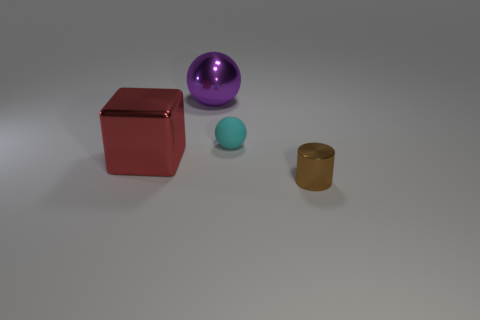Add 4 small brown cylinders. How many objects exist? 8 Subtract all cubes. How many objects are left? 3 Add 2 tiny balls. How many tiny balls are left? 3 Add 4 large gray objects. How many large gray objects exist? 4 Subtract 0 green blocks. How many objects are left? 4 Subtract 2 balls. How many balls are left? 0 Subtract all purple cubes. Subtract all brown spheres. How many cubes are left? 1 Subtract all big brown metal cylinders. Subtract all metallic things. How many objects are left? 1 